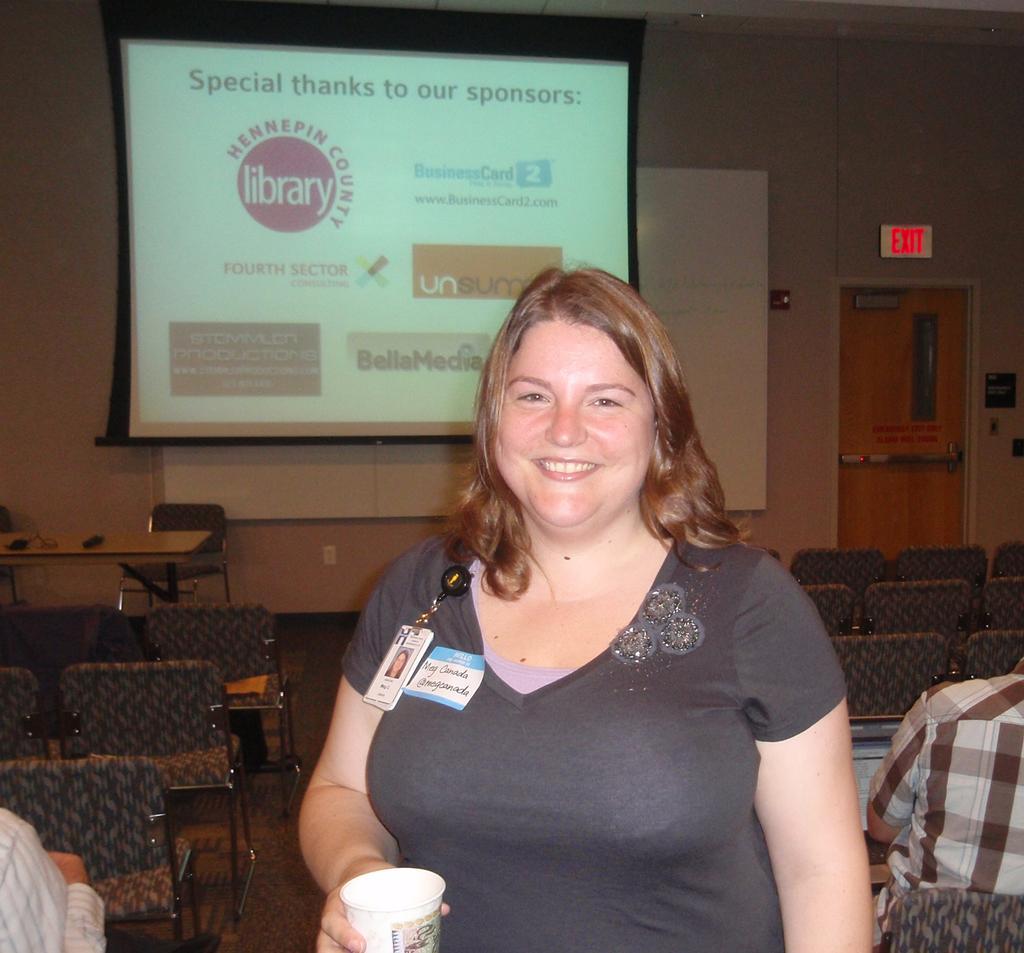Could you give a brief overview of what you see in this image? In this picture we can see a woman holding a cup and smiling at someone. In the background, we see a projector display and chairs. 